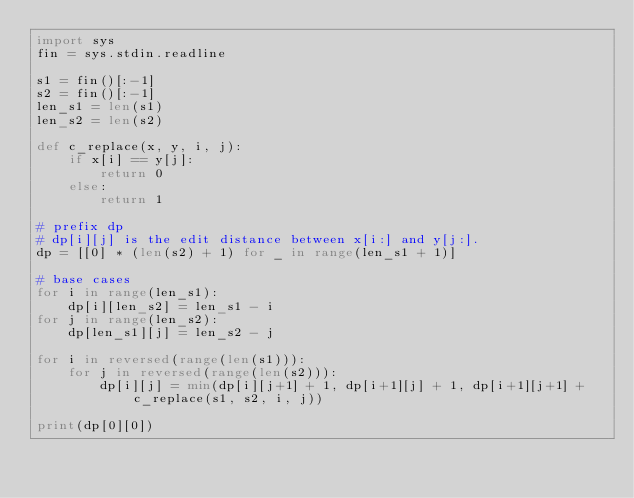<code> <loc_0><loc_0><loc_500><loc_500><_Python_>import sys
fin = sys.stdin.readline

s1 = fin()[:-1]
s2 = fin()[:-1]
len_s1 = len(s1)
len_s2 = len(s2)

def c_replace(x, y, i, j):
    if x[i] == y[j]:
        return 0
    else:
        return 1

# prefix dp
# dp[i][j] is the edit distance between x[i:] and y[j:].
dp = [[0] * (len(s2) + 1) for _ in range(len_s1 + 1)]

# base cases
for i in range(len_s1):
    dp[i][len_s2] = len_s1 - i
for j in range(len_s2):
    dp[len_s1][j] = len_s2 - j

for i in reversed(range(len(s1))):
    for j in reversed(range(len(s2))):
        dp[i][j] = min(dp[i][j+1] + 1, dp[i+1][j] + 1, dp[i+1][j+1] + c_replace(s1, s2, i, j))

print(dp[0][0])

</code> 